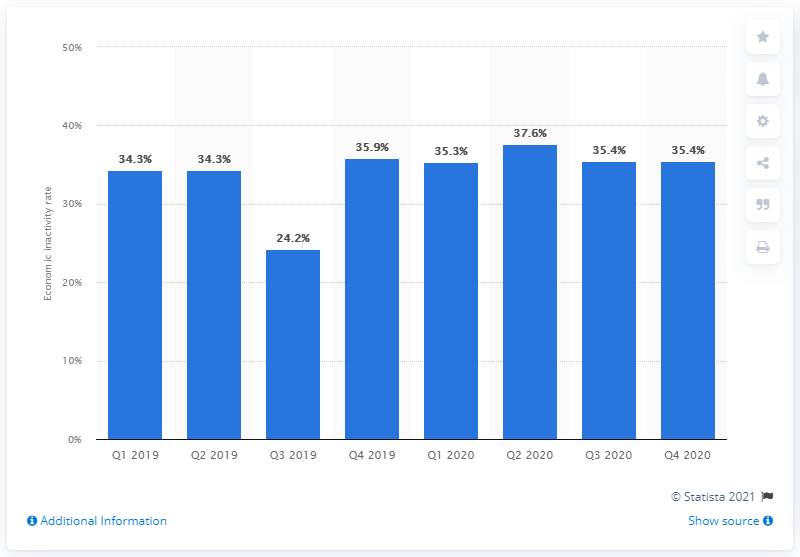Identify some key points in this picture. In the fourth quarter of 2020, the economic inactivity rate of people aged 15 to 64 years in Italy was 35.4%. 